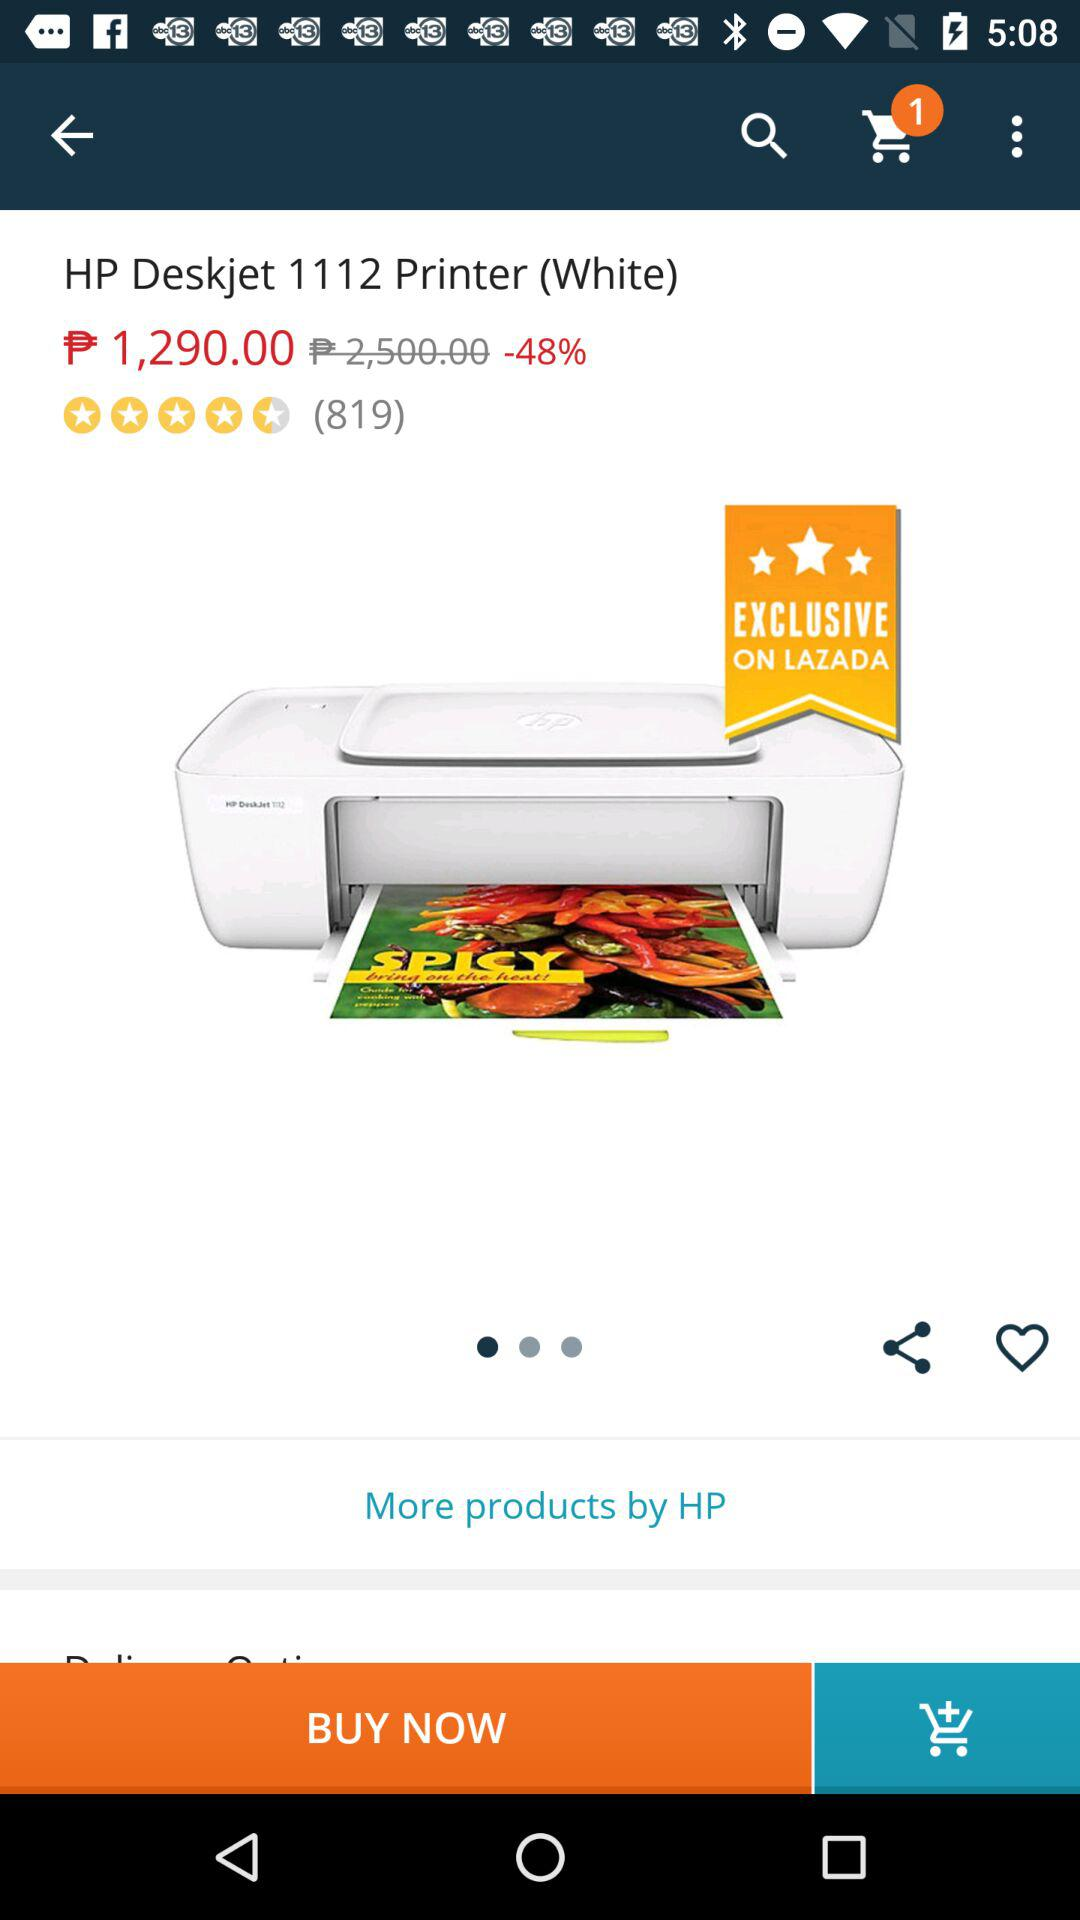What is the discount percentage? The discount percentage is 48. 